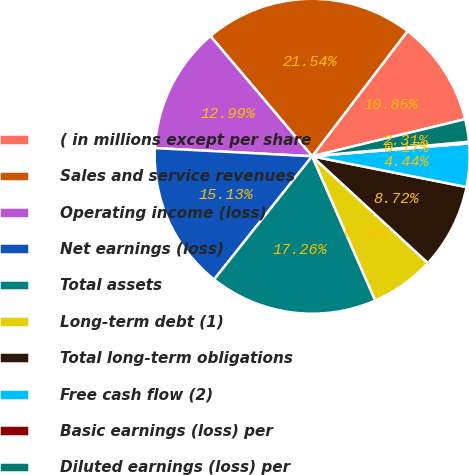Convert chart. <chart><loc_0><loc_0><loc_500><loc_500><pie_chart><fcel>( in millions except per share<fcel>Sales and service revenues<fcel>Operating income (loss)<fcel>Net earnings (loss)<fcel>Total assets<fcel>Long-term debt (1)<fcel>Total long-term obligations<fcel>Free cash flow (2)<fcel>Basic earnings (loss) per<fcel>Diluted earnings (loss) per<nl><fcel>10.85%<fcel>21.54%<fcel>12.99%<fcel>15.13%<fcel>17.26%<fcel>6.58%<fcel>8.72%<fcel>4.44%<fcel>0.17%<fcel>2.31%<nl></chart> 